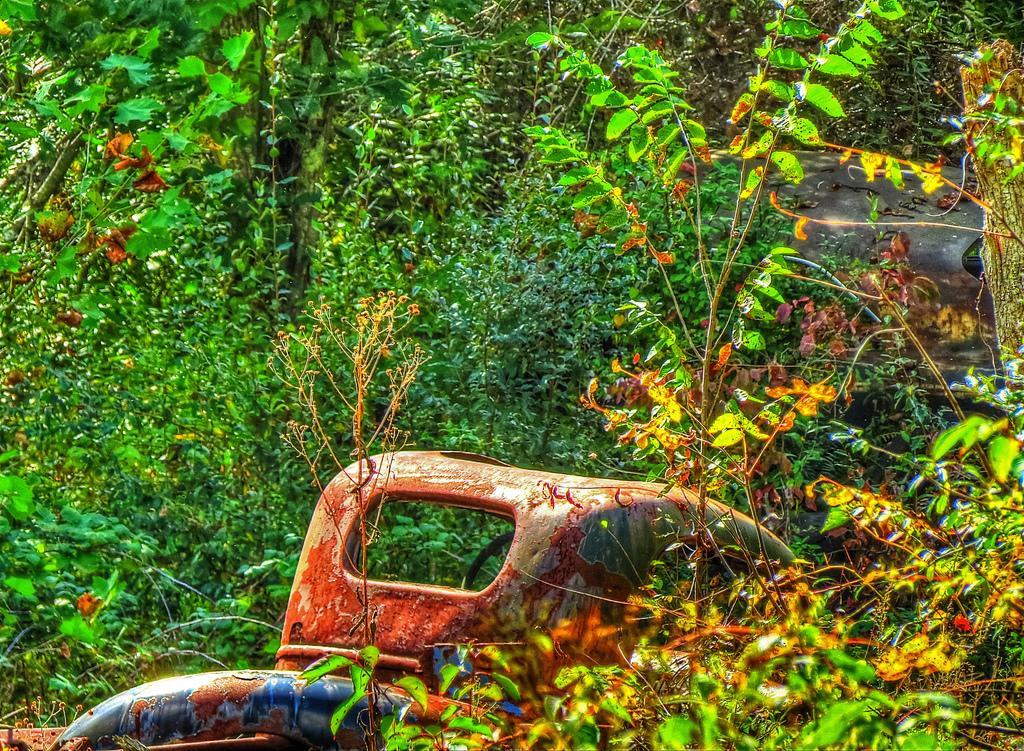What is the main subject of the image? There is a vehicle in the image. What can be seen in the background of the image? There are trees visible in the background of the image. How many chairs are placed around the vehicle in the image? There are no chairs present in the image; it only features a vehicle and trees in the background. 